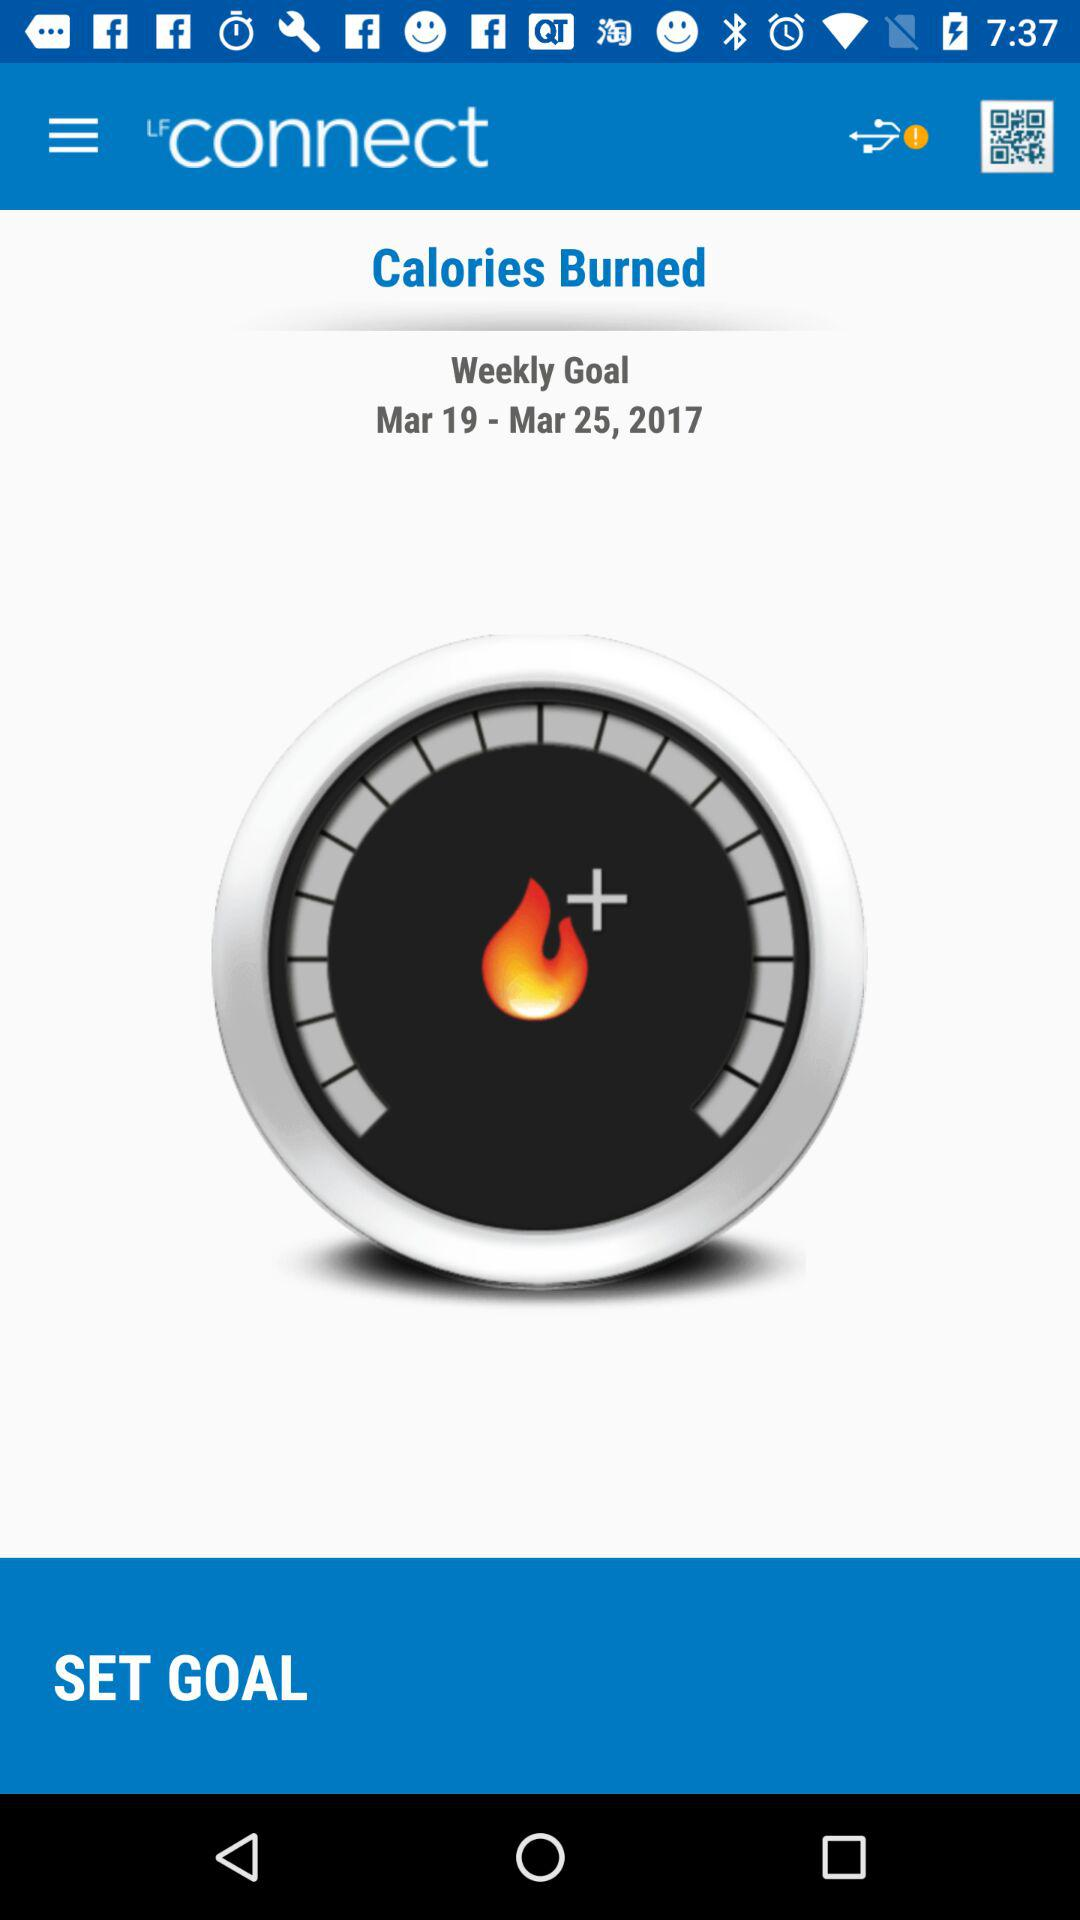What is the given date? The given date is from March 19, 2017 to March 25, 2017. 